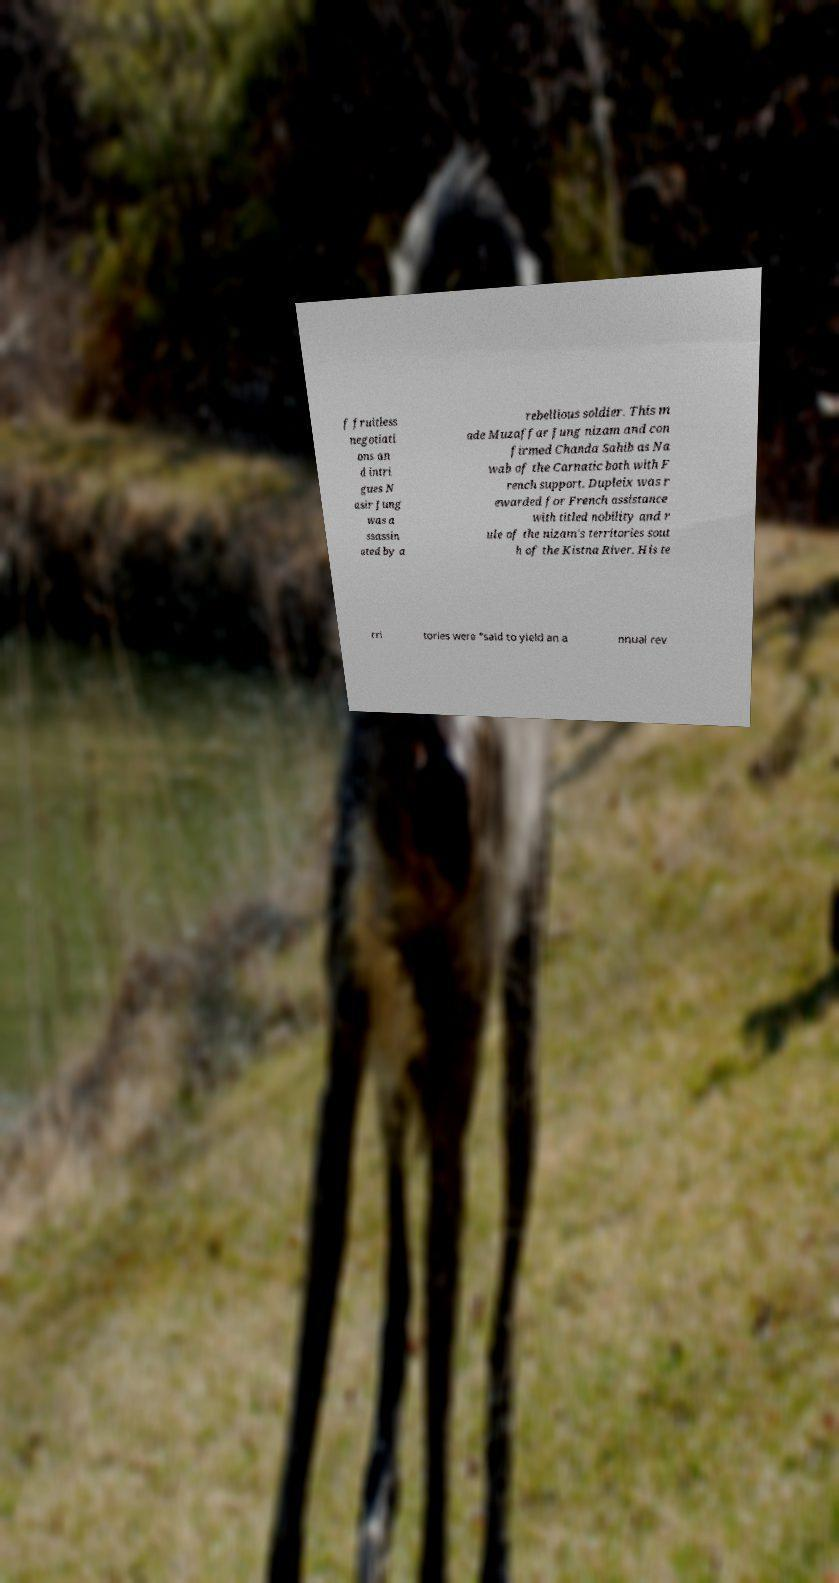I need the written content from this picture converted into text. Can you do that? f fruitless negotiati ons an d intri gues N asir Jung was a ssassin ated by a rebellious soldier. This m ade Muzaffar Jung nizam and con firmed Chanda Sahib as Na wab of the Carnatic both with F rench support. Dupleix was r ewarded for French assistance with titled nobility and r ule of the nizam's territories sout h of the Kistna River. His te rri tories were "said to yield an a nnual rev 